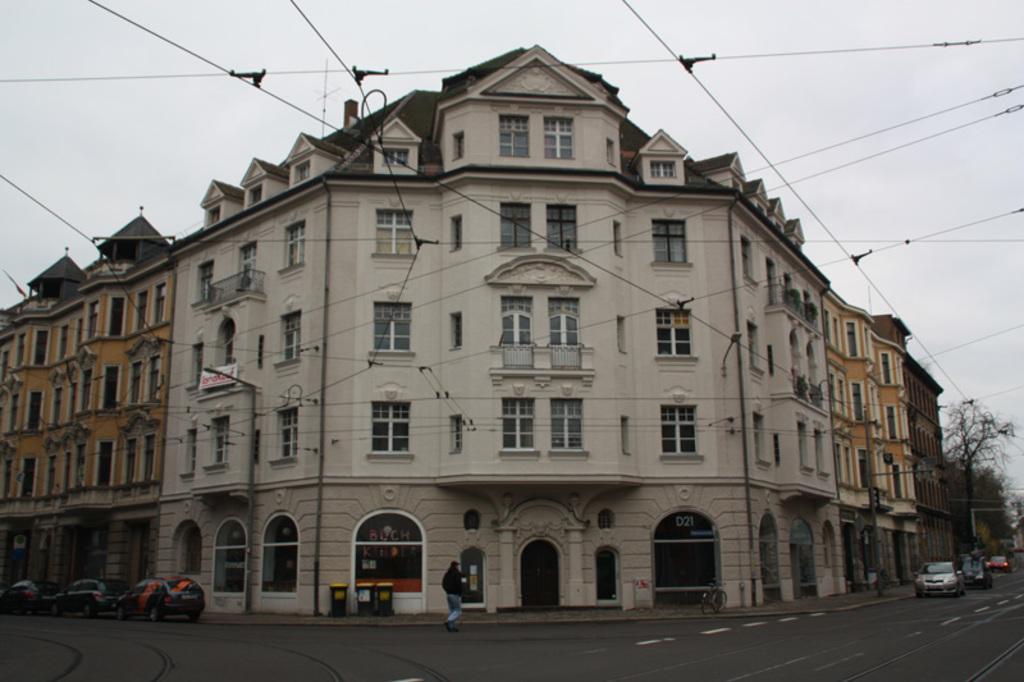In one or two sentences, can you explain what this image depicts? There are vehicles, trash bins and a person at the bottom side of the image, there are buildings in the foreground and trees on the right side. There are wires at the top side and the sky in the background. 